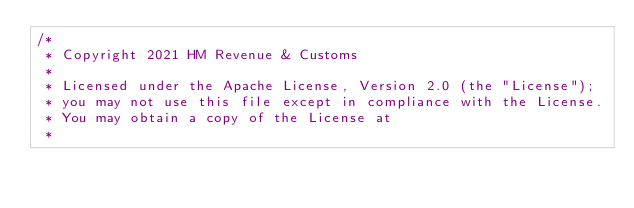<code> <loc_0><loc_0><loc_500><loc_500><_Scala_>/*
 * Copyright 2021 HM Revenue & Customs
 *
 * Licensed under the Apache License, Version 2.0 (the "License");
 * you may not use this file except in compliance with the License.
 * You may obtain a copy of the License at
 *</code> 